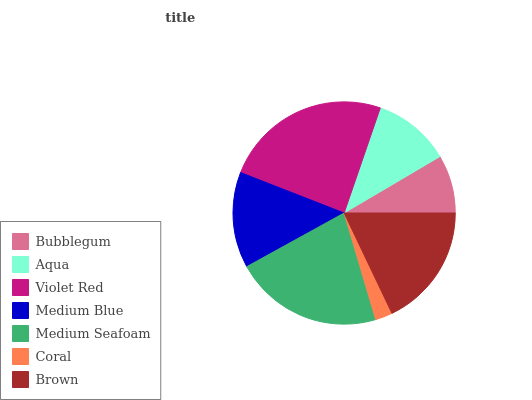Is Coral the minimum?
Answer yes or no. Yes. Is Violet Red the maximum?
Answer yes or no. Yes. Is Aqua the minimum?
Answer yes or no. No. Is Aqua the maximum?
Answer yes or no. No. Is Aqua greater than Bubblegum?
Answer yes or no. Yes. Is Bubblegum less than Aqua?
Answer yes or no. Yes. Is Bubblegum greater than Aqua?
Answer yes or no. No. Is Aqua less than Bubblegum?
Answer yes or no. No. Is Medium Blue the high median?
Answer yes or no. Yes. Is Medium Blue the low median?
Answer yes or no. Yes. Is Coral the high median?
Answer yes or no. No. Is Coral the low median?
Answer yes or no. No. 